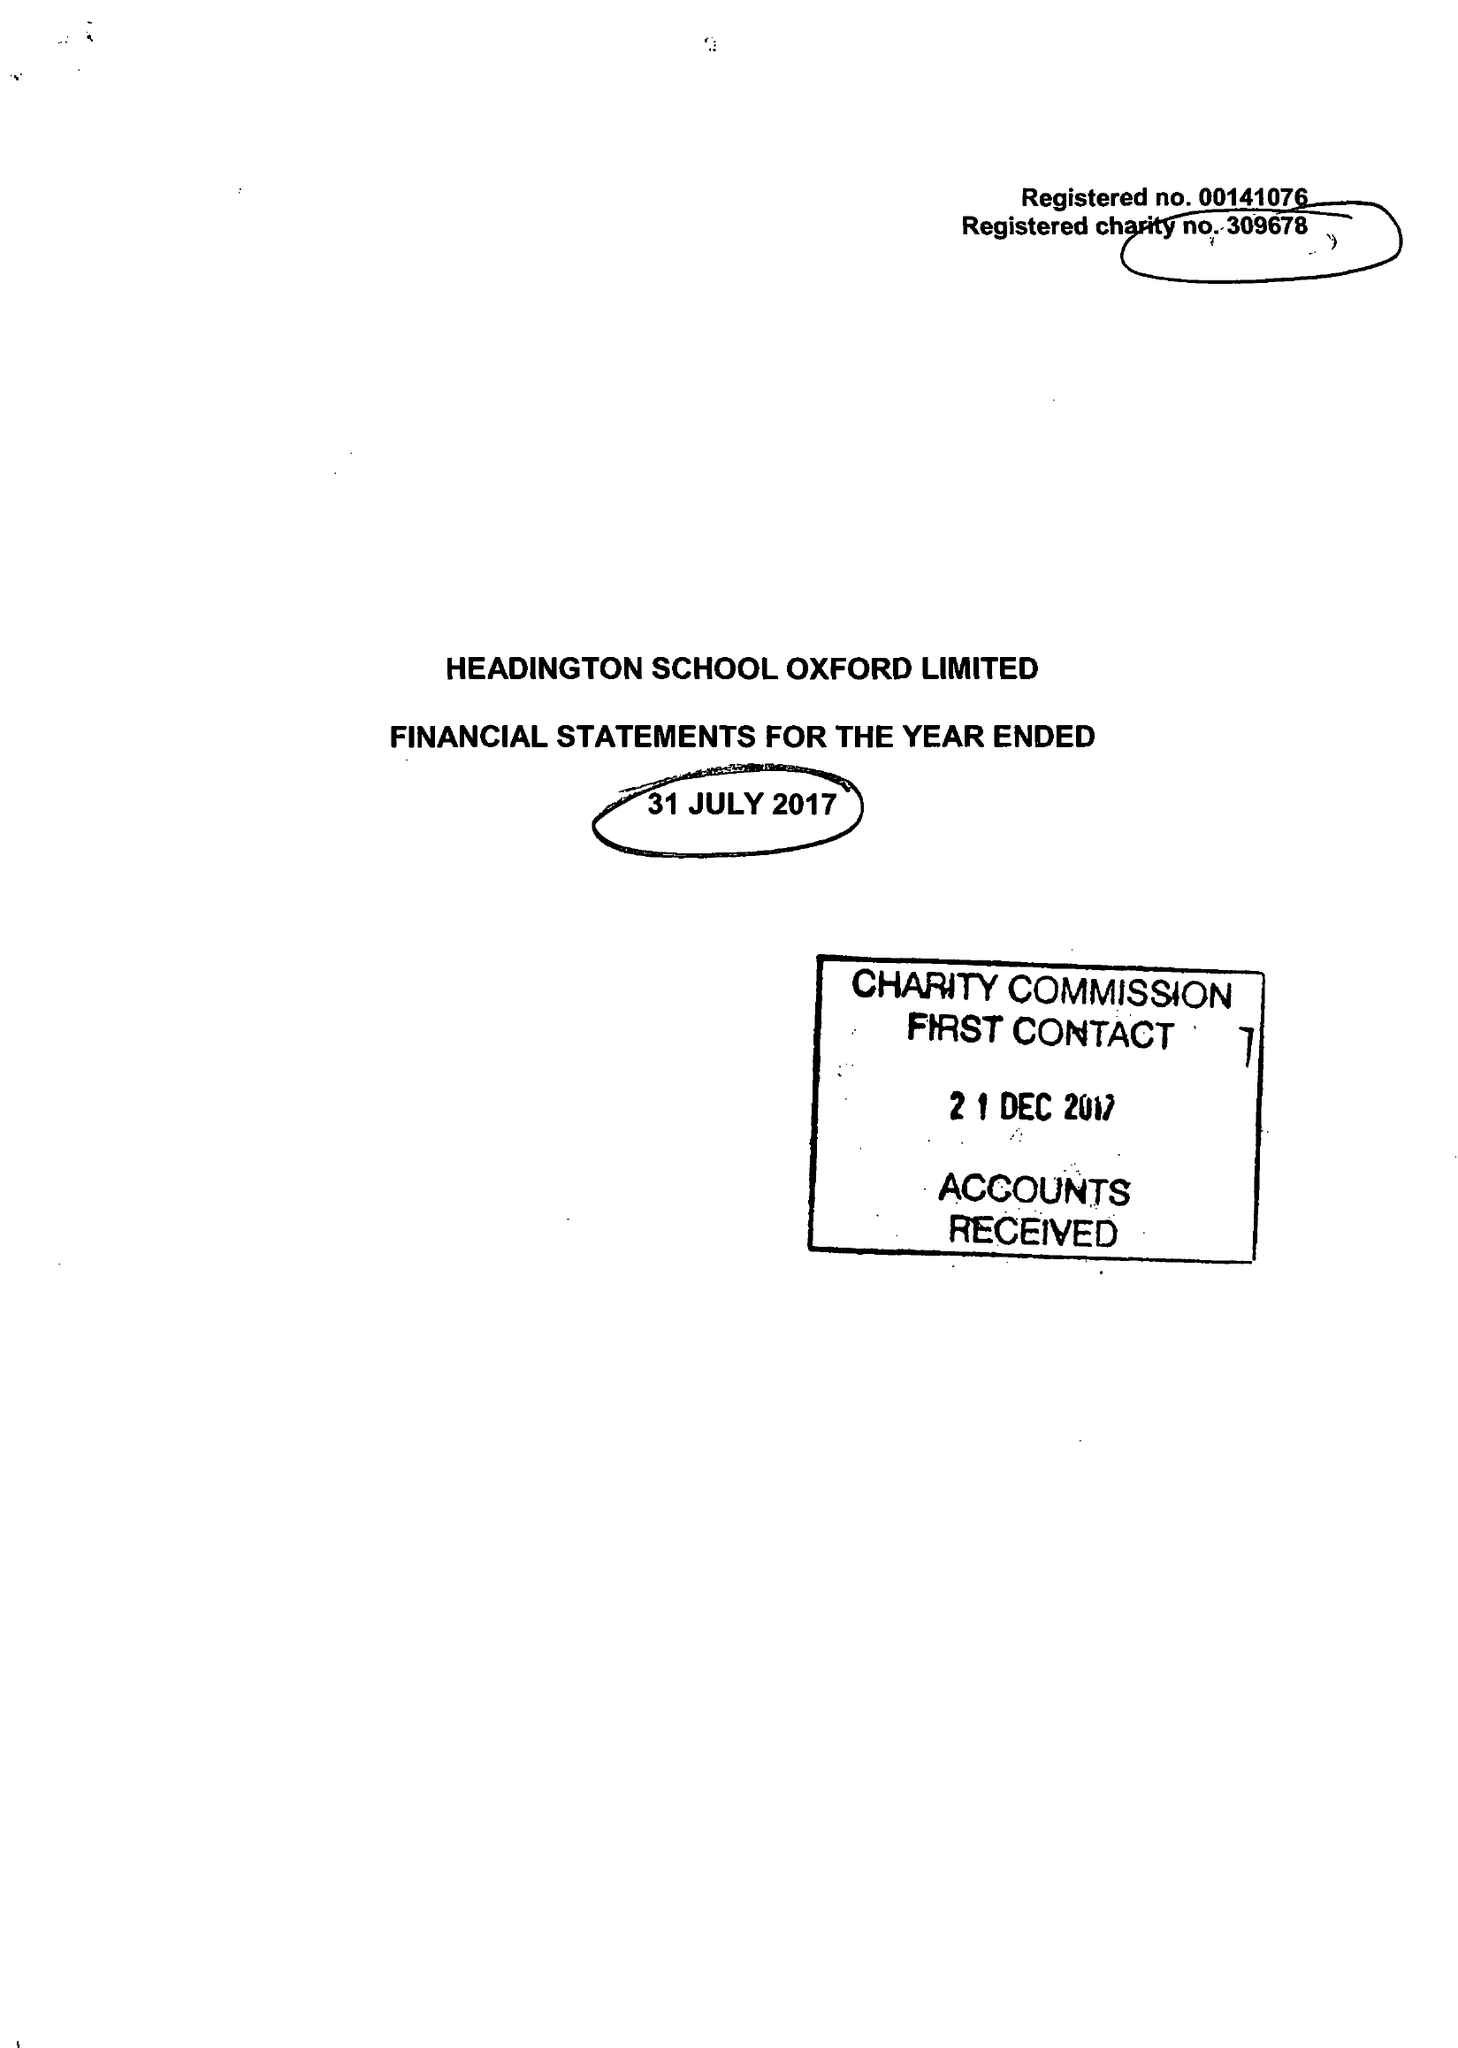What is the value for the address__post_town?
Answer the question using a single word or phrase. OXFORD 